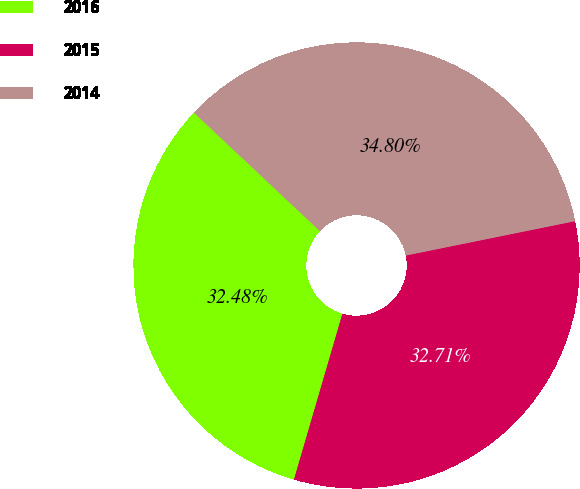<chart> <loc_0><loc_0><loc_500><loc_500><pie_chart><fcel>2016<fcel>2015<fcel>2014<nl><fcel>32.48%<fcel>32.71%<fcel>34.8%<nl></chart> 